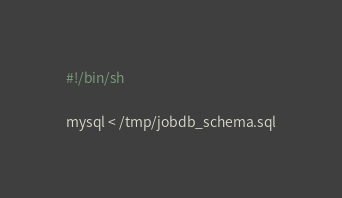<code> <loc_0><loc_0><loc_500><loc_500><_Bash_>#!/bin/sh

mysql < /tmp/jobdb_schema.sql</code> 